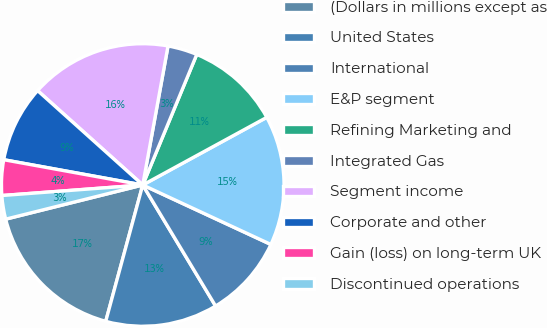<chart> <loc_0><loc_0><loc_500><loc_500><pie_chart><fcel>(Dollars in millions except as<fcel>United States<fcel>International<fcel>E&P segment<fcel>Refining Marketing and<fcel>Integrated Gas<fcel>Segment income<fcel>Corporate and other<fcel>Gain (loss) on long-term UK<fcel>Discontinued operations<nl><fcel>16.89%<fcel>12.84%<fcel>9.46%<fcel>14.86%<fcel>10.81%<fcel>3.38%<fcel>16.22%<fcel>8.78%<fcel>4.05%<fcel>2.7%<nl></chart> 